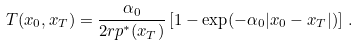Convert formula to latex. <formula><loc_0><loc_0><loc_500><loc_500>T ( x _ { 0 } , x _ { T } ) = \frac { \alpha _ { 0 } } { 2 r p ^ { * } ( x _ { T } ) } \left [ 1 - \exp ( - \alpha _ { 0 } | x _ { 0 } - x _ { T } | ) \right ] \, .</formula> 